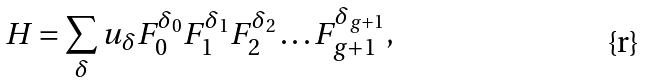Convert formula to latex. <formula><loc_0><loc_0><loc_500><loc_500>H = \sum _ { \delta } u _ { \delta } F _ { 0 } ^ { \delta _ { 0 } } F _ { 1 } ^ { \delta _ { 1 } } F _ { 2 } ^ { \delta _ { 2 } } \dots F _ { g + 1 } ^ { \delta _ { g + 1 } } ,</formula> 